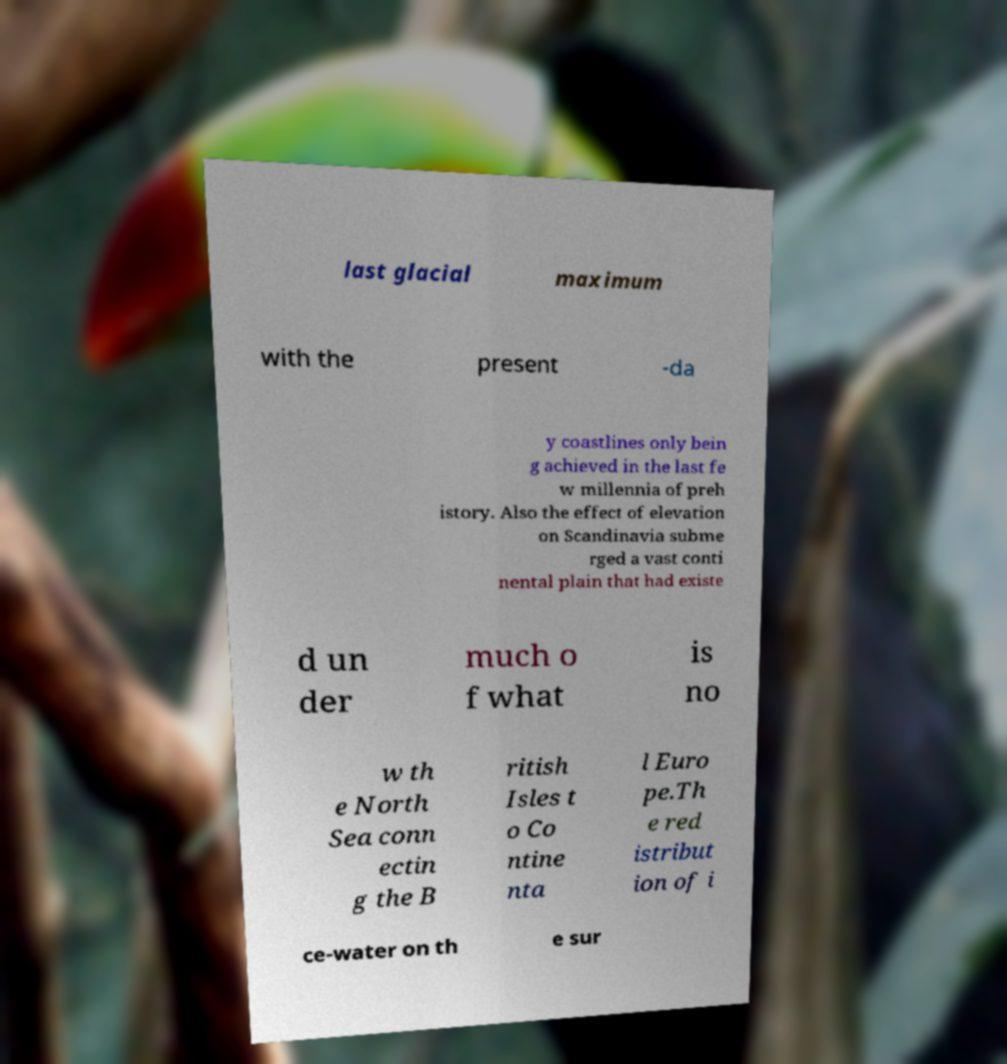Please read and relay the text visible in this image. What does it say? last glacial maximum with the present -da y coastlines only bein g achieved in the last fe w millennia of preh istory. Also the effect of elevation on Scandinavia subme rged a vast conti nental plain that had existe d un der much o f what is no w th e North Sea conn ectin g the B ritish Isles t o Co ntine nta l Euro pe.Th e red istribut ion of i ce-water on th e sur 